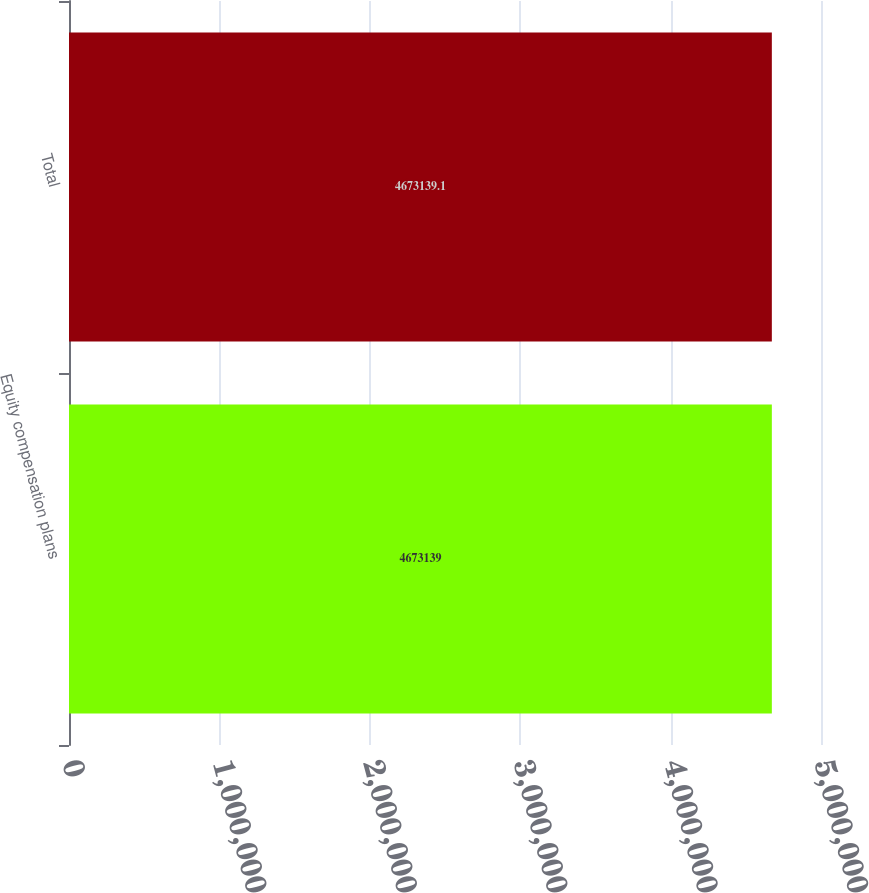<chart> <loc_0><loc_0><loc_500><loc_500><bar_chart><fcel>Equity compensation plans<fcel>Total<nl><fcel>4.67314e+06<fcel>4.67314e+06<nl></chart> 